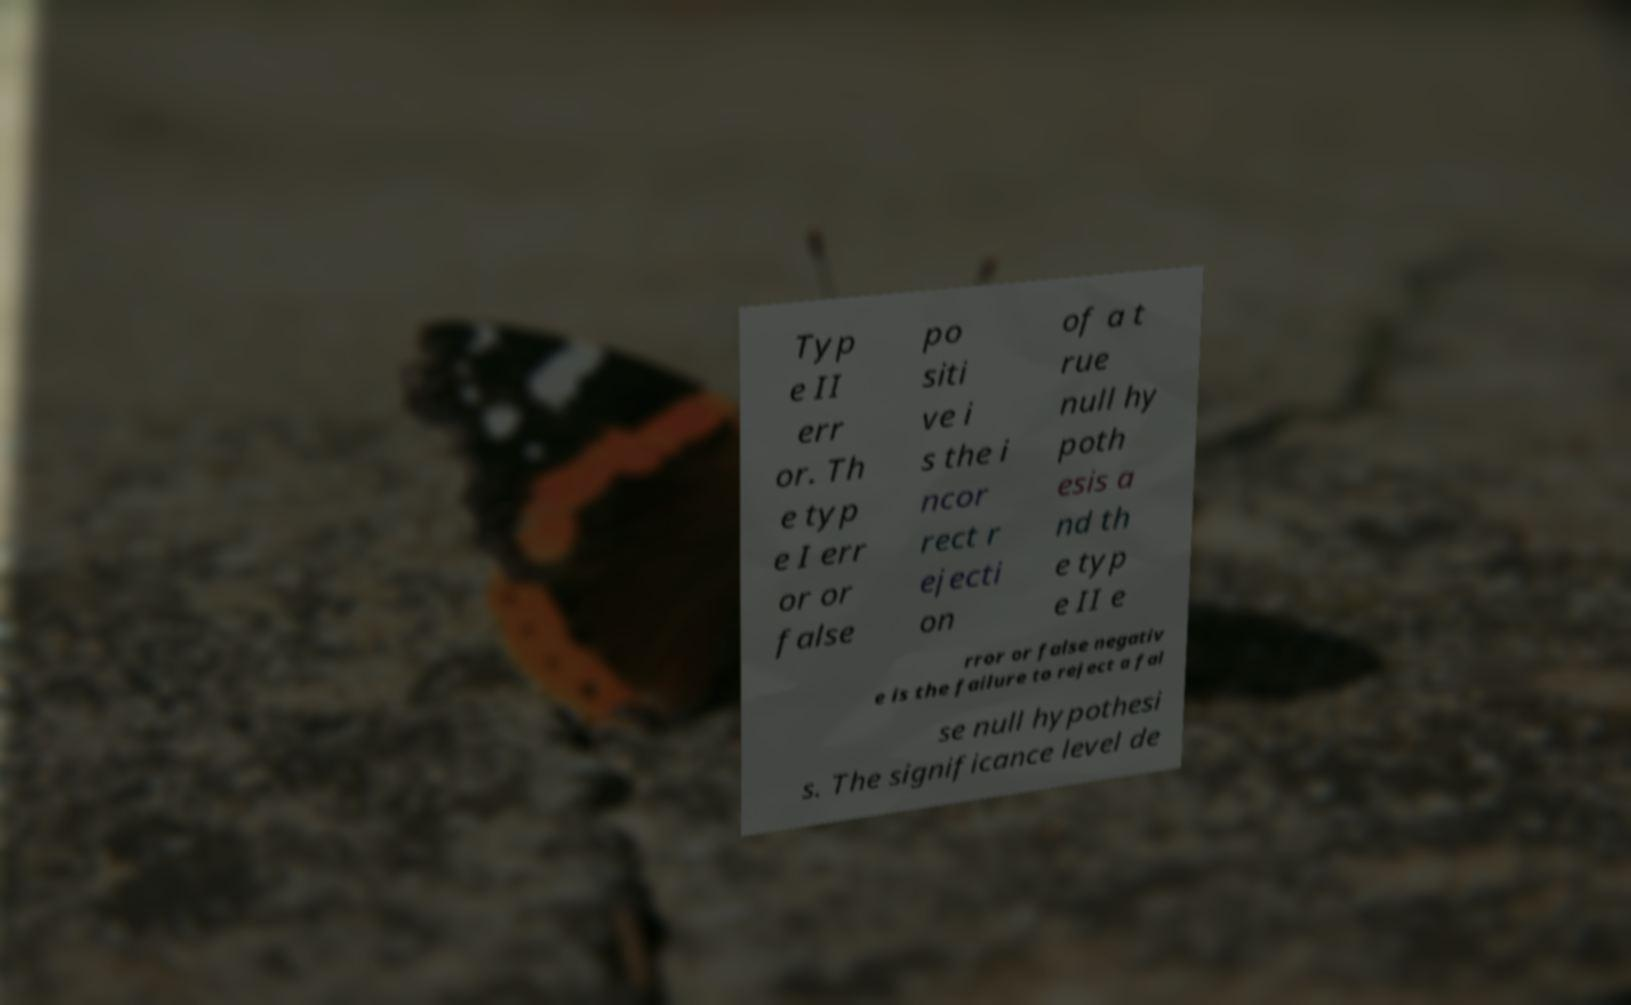For documentation purposes, I need the text within this image transcribed. Could you provide that? Typ e II err or. Th e typ e I err or or false po siti ve i s the i ncor rect r ejecti on of a t rue null hy poth esis a nd th e typ e II e rror or false negativ e is the failure to reject a fal se null hypothesi s. The significance level de 